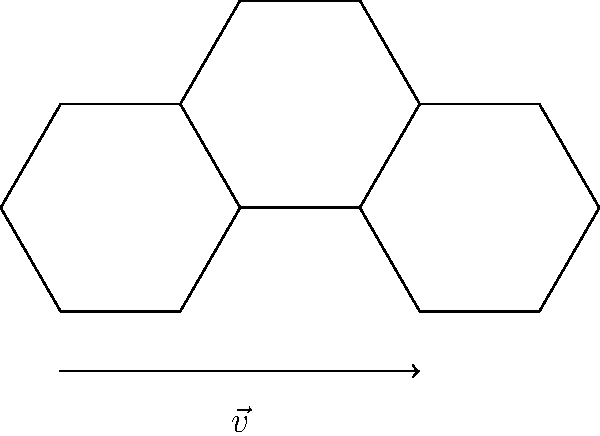In the honeycomb structure shown above, what is the translational symmetry vector $\vec{v}$ that maps the leftmost hexagon to the rightmost hexagon? To find the translational symmetry vector $\vec{v}$, we need to follow these steps:

1. Identify the centers of the leftmost and rightmost hexagons.
   - Leftmost hexagon center: $(0,0)$
   - Rightmost hexagon center: $(3a,0)$

2. Calculate the displacement vector between these centers:
   $\vec{v} = (3a,0) - (0,0) = (3a,0)$

3. Express the vector in terms of the hexagon's side length $a$:
   $\vec{v} = 3a\hat{i} + 0\hat{j} = 3a\hat{i}$

4. Verify that this vector indeed maps the leftmost hexagon to the rightmost hexagon:
   - Applying $\vec{v}$ to any point $(x,y)$ in the leftmost hexagon:
     $(x,y) + (3a,0) = (x+3a,y)$
   This results in the corresponding point in the rightmost hexagon.

Therefore, the translational symmetry vector $\vec{v}$ that maps the leftmost hexagon to the rightmost hexagon is $3a\hat{i}$.
Answer: $3a\hat{i}$ 